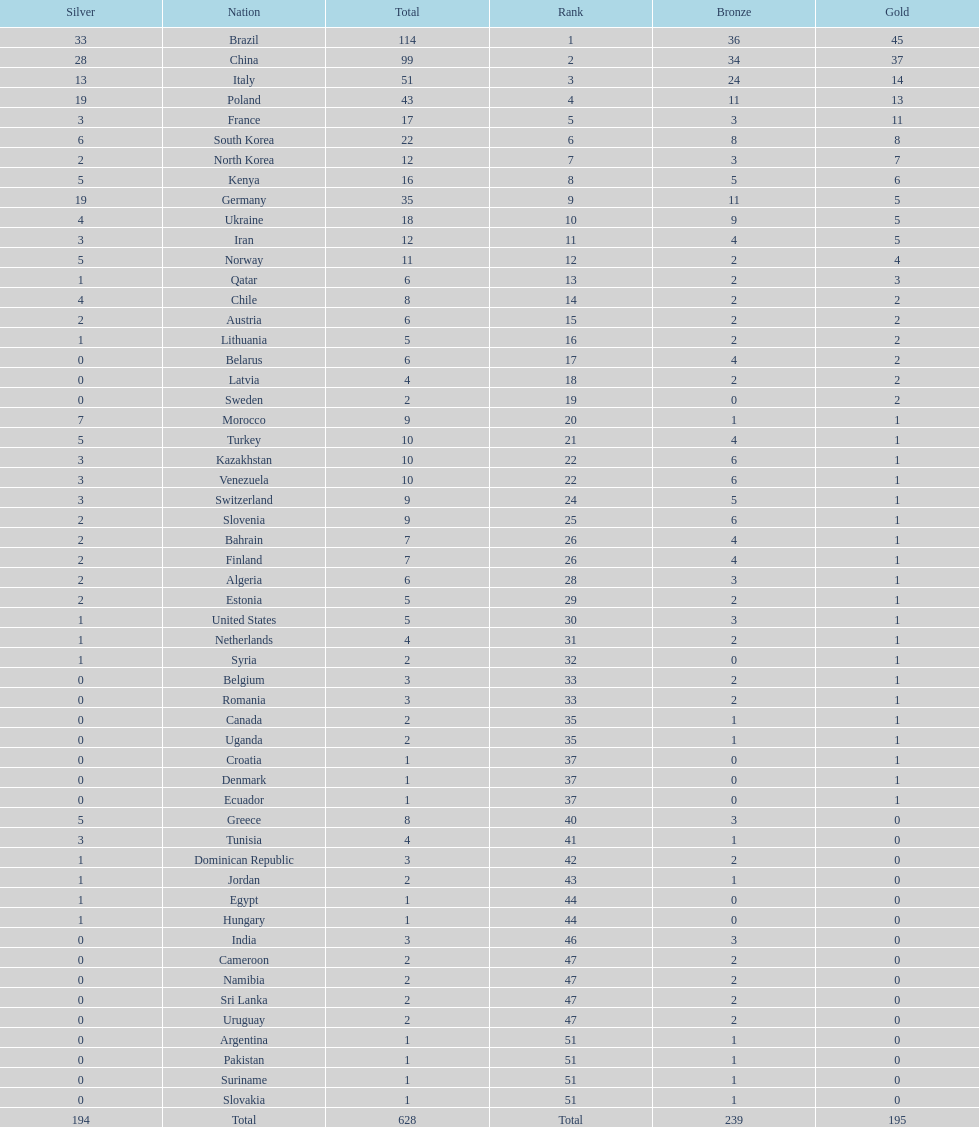Who merely achieved 13 silver medals? Italy. Would you be able to parse every entry in this table? {'header': ['Silver', 'Nation', 'Total', 'Rank', 'Bronze', 'Gold'], 'rows': [['33', 'Brazil', '114', '1', '36', '45'], ['28', 'China', '99', '2', '34', '37'], ['13', 'Italy', '51', '3', '24', '14'], ['19', 'Poland', '43', '4', '11', '13'], ['3', 'France', '17', '5', '3', '11'], ['6', 'South Korea', '22', '6', '8', '8'], ['2', 'North Korea', '12', '7', '3', '7'], ['5', 'Kenya', '16', '8', '5', '6'], ['19', 'Germany', '35', '9', '11', '5'], ['4', 'Ukraine', '18', '10', '9', '5'], ['3', 'Iran', '12', '11', '4', '5'], ['5', 'Norway', '11', '12', '2', '4'], ['1', 'Qatar', '6', '13', '2', '3'], ['4', 'Chile', '8', '14', '2', '2'], ['2', 'Austria', '6', '15', '2', '2'], ['1', 'Lithuania', '5', '16', '2', '2'], ['0', 'Belarus', '6', '17', '4', '2'], ['0', 'Latvia', '4', '18', '2', '2'], ['0', 'Sweden', '2', '19', '0', '2'], ['7', 'Morocco', '9', '20', '1', '1'], ['5', 'Turkey', '10', '21', '4', '1'], ['3', 'Kazakhstan', '10', '22', '6', '1'], ['3', 'Venezuela', '10', '22', '6', '1'], ['3', 'Switzerland', '9', '24', '5', '1'], ['2', 'Slovenia', '9', '25', '6', '1'], ['2', 'Bahrain', '7', '26', '4', '1'], ['2', 'Finland', '7', '26', '4', '1'], ['2', 'Algeria', '6', '28', '3', '1'], ['2', 'Estonia', '5', '29', '2', '1'], ['1', 'United States', '5', '30', '3', '1'], ['1', 'Netherlands', '4', '31', '2', '1'], ['1', 'Syria', '2', '32', '0', '1'], ['0', 'Belgium', '3', '33', '2', '1'], ['0', 'Romania', '3', '33', '2', '1'], ['0', 'Canada', '2', '35', '1', '1'], ['0', 'Uganda', '2', '35', '1', '1'], ['0', 'Croatia', '1', '37', '0', '1'], ['0', 'Denmark', '1', '37', '0', '1'], ['0', 'Ecuador', '1', '37', '0', '1'], ['5', 'Greece', '8', '40', '3', '0'], ['3', 'Tunisia', '4', '41', '1', '0'], ['1', 'Dominican Republic', '3', '42', '2', '0'], ['1', 'Jordan', '2', '43', '1', '0'], ['1', 'Egypt', '1', '44', '0', '0'], ['1', 'Hungary', '1', '44', '0', '0'], ['0', 'India', '3', '46', '3', '0'], ['0', 'Cameroon', '2', '47', '2', '0'], ['0', 'Namibia', '2', '47', '2', '0'], ['0', 'Sri Lanka', '2', '47', '2', '0'], ['0', 'Uruguay', '2', '47', '2', '0'], ['0', 'Argentina', '1', '51', '1', '0'], ['0', 'Pakistan', '1', '51', '1', '0'], ['0', 'Suriname', '1', '51', '1', '0'], ['0', 'Slovakia', '1', '51', '1', '0'], ['194', 'Total', '628', 'Total', '239', '195']]} 